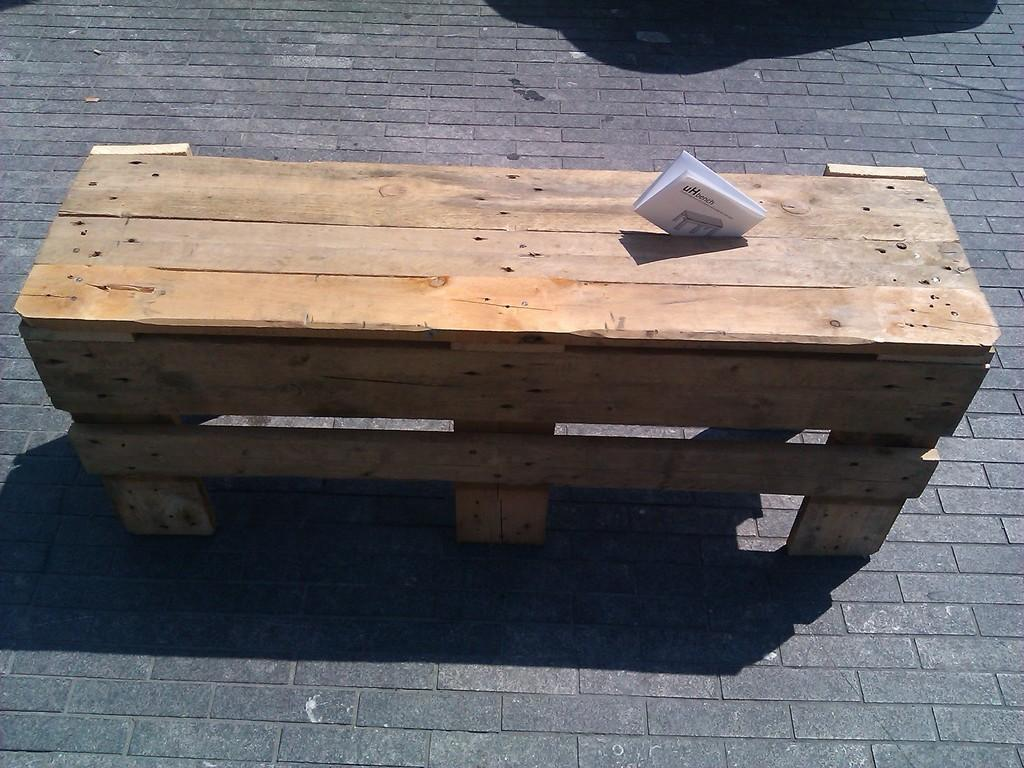What type of seating is visible in the image? There is a wooden bench in the image. What object is located in the foreground area of the image? A paper is present in the foreground area of the image. Can you describe any visual effects in the image? There is a shadow at the top side of the image. What type of wealth is being offered on the wooden bench in the image? There is no indication of wealth or any offer in the image; it only features a wooden bench and a paper in the foreground. 